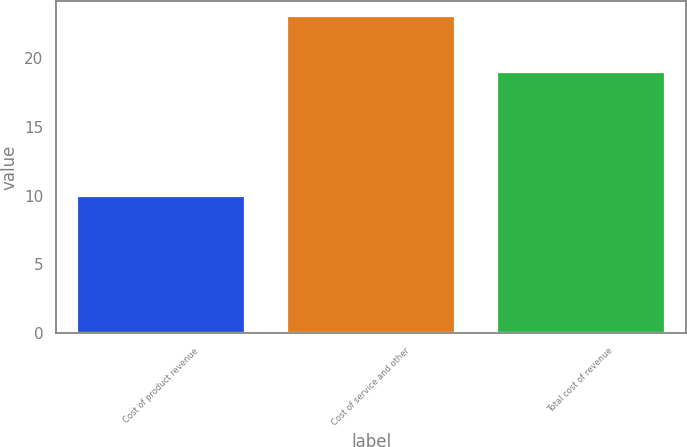Convert chart to OTSL. <chart><loc_0><loc_0><loc_500><loc_500><bar_chart><fcel>Cost of product revenue<fcel>Cost of service and other<fcel>Total cost of revenue<nl><fcel>10<fcel>23<fcel>19<nl></chart> 